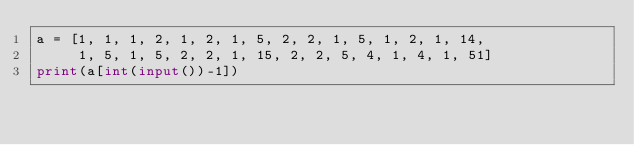Convert code to text. <code><loc_0><loc_0><loc_500><loc_500><_Python_>a = [1, 1, 1, 2, 1, 2, 1, 5, 2, 2, 1, 5, 1, 2, 1, 14,
     1, 5, 1, 5, 2, 2, 1, 15, 2, 2, 5, 4, 1, 4, 1, 51]
print(a[int(input())-1])
</code> 